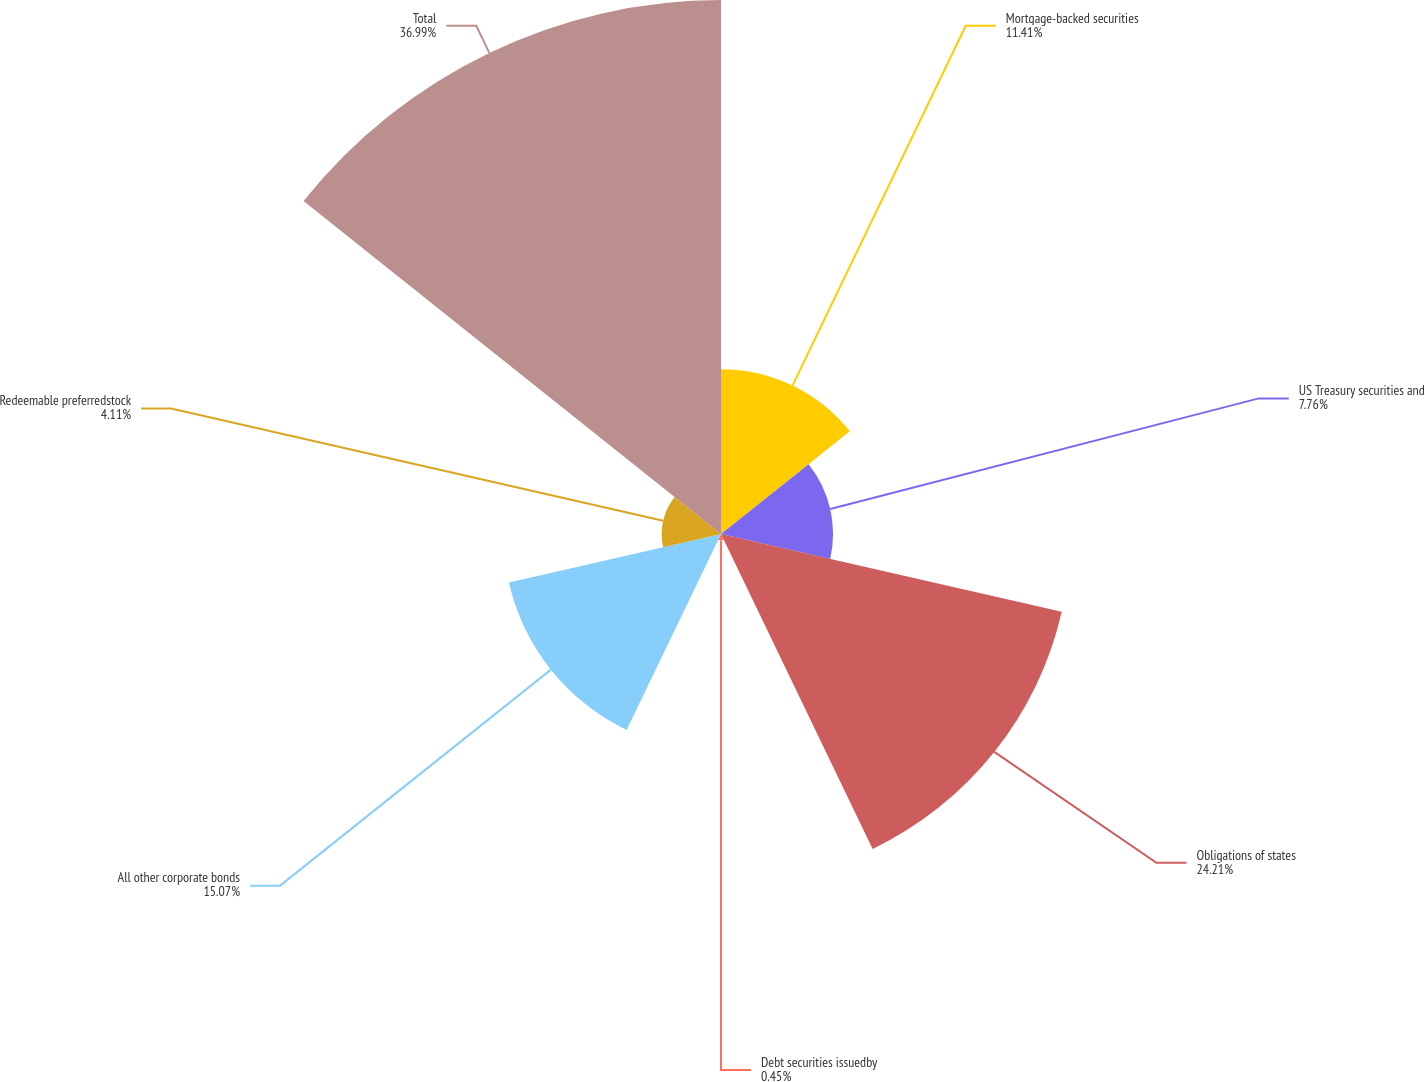<chart> <loc_0><loc_0><loc_500><loc_500><pie_chart><fcel>Mortgage-backed securities<fcel>US Treasury securities and<fcel>Obligations of states<fcel>Debt securities issuedby<fcel>All other corporate bonds<fcel>Redeemable preferredstock<fcel>Total<nl><fcel>11.41%<fcel>7.76%<fcel>24.21%<fcel>0.45%<fcel>15.07%<fcel>4.11%<fcel>36.99%<nl></chart> 